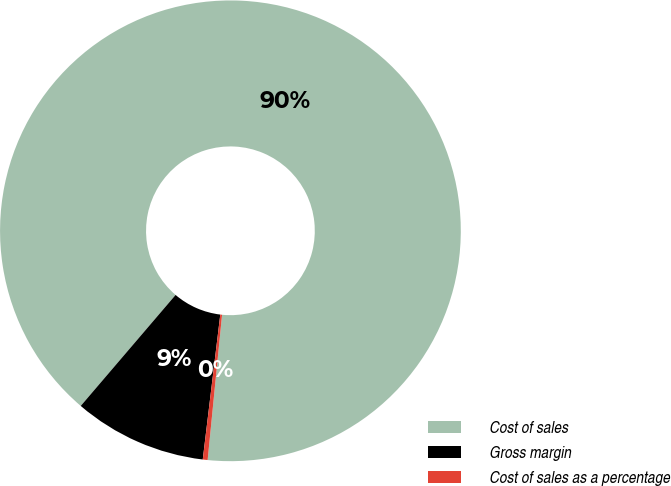Convert chart. <chart><loc_0><loc_0><loc_500><loc_500><pie_chart><fcel>Cost of sales<fcel>Gross margin<fcel>Cost of sales as a percentage<nl><fcel>90.33%<fcel>9.34%<fcel>0.34%<nl></chart> 